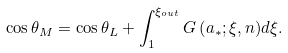<formula> <loc_0><loc_0><loc_500><loc_500>\cos \theta _ { M } = \cos \theta _ { L } + \int _ { 1 } ^ { \xi _ { o u t } } { G \left ( { a _ { * } ; \xi , n } \right ) } d \xi .</formula> 